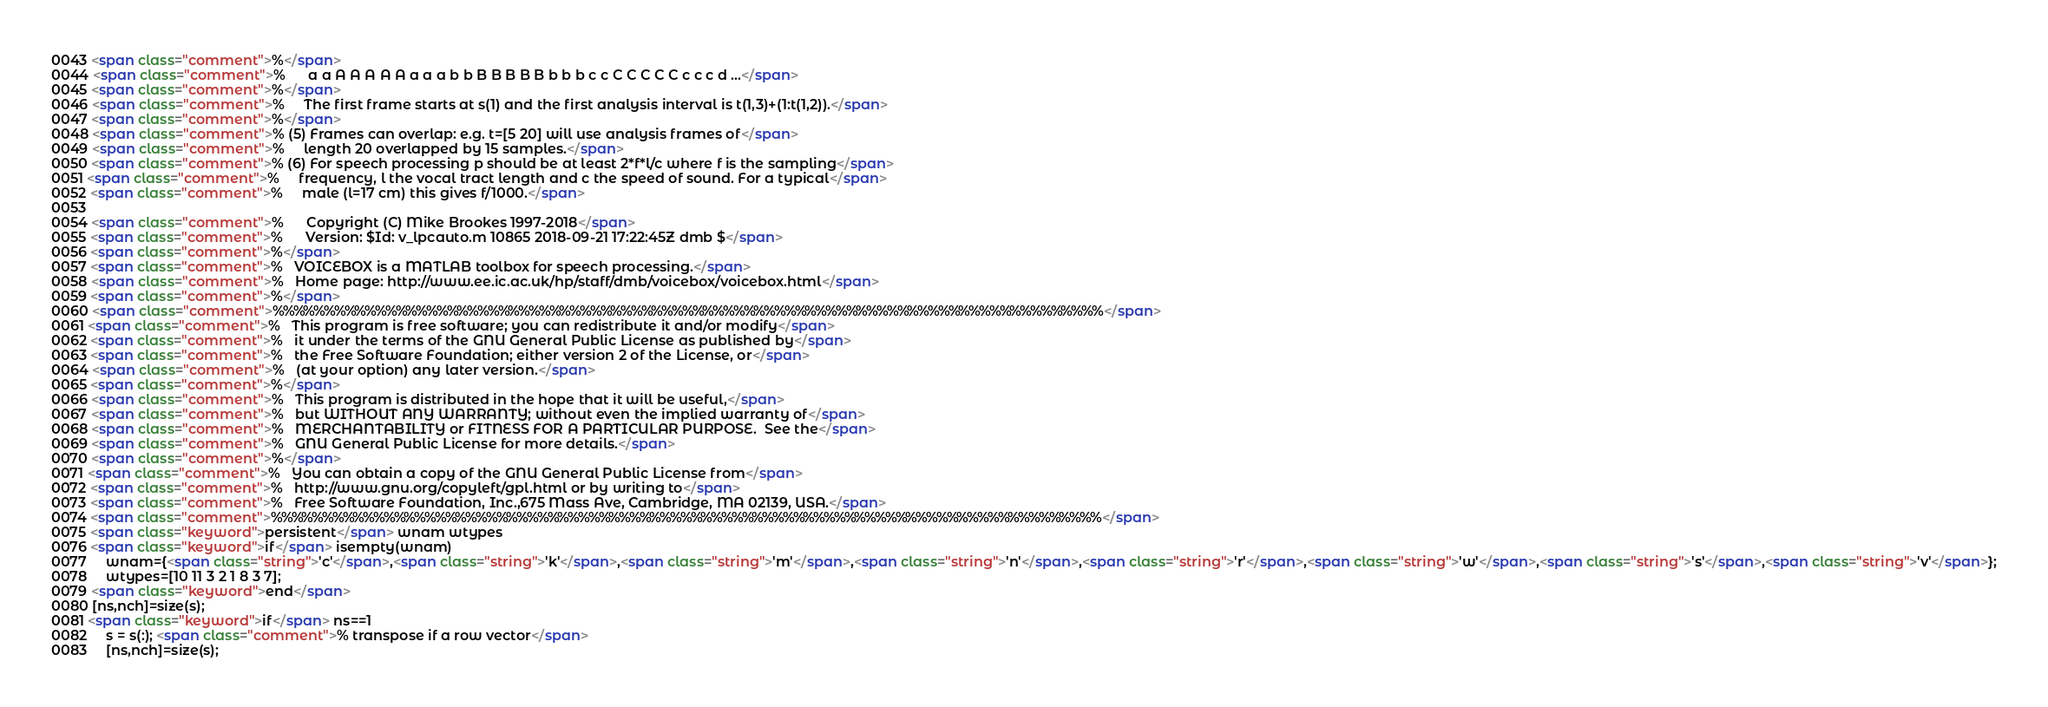<code> <loc_0><loc_0><loc_500><loc_500><_HTML_>0043 <span class="comment">%</span>
0044 <span class="comment">%      a a A A A A A a a a b b B B B B B b b b c c C C C C C c c c d ...</span>
0045 <span class="comment">%</span>
0046 <span class="comment">%     The first frame starts at s(1) and the first analysis interval is t(1,3)+(1:t(1,2)).</span>
0047 <span class="comment">%</span>
0048 <span class="comment">% (5) Frames can overlap: e.g. t=[5 20] will use analysis frames of</span>
0049 <span class="comment">%     length 20 overlapped by 15 samples.</span>
0050 <span class="comment">% (6) For speech processing p should be at least 2*f*l/c where f is the sampling</span>
0051 <span class="comment">%     frequency, l the vocal tract length and c the speed of sound. For a typical</span>
0052 <span class="comment">%     male (l=17 cm) this gives f/1000.</span>
0053 
0054 <span class="comment">%      Copyright (C) Mike Brookes 1997-2018</span>
0055 <span class="comment">%      Version: $Id: v_lpcauto.m 10865 2018-09-21 17:22:45Z dmb $</span>
0056 <span class="comment">%</span>
0057 <span class="comment">%   VOICEBOX is a MATLAB toolbox for speech processing.</span>
0058 <span class="comment">%   Home page: http://www.ee.ic.ac.uk/hp/staff/dmb/voicebox/voicebox.html</span>
0059 <span class="comment">%</span>
0060 <span class="comment">%%%%%%%%%%%%%%%%%%%%%%%%%%%%%%%%%%%%%%%%%%%%%%%%%%%%%%%%%%%%%%%%%%%%%%%%%%%%%%%%%</span>
0061 <span class="comment">%   This program is free software; you can redistribute it and/or modify</span>
0062 <span class="comment">%   it under the terms of the GNU General Public License as published by</span>
0063 <span class="comment">%   the Free Software Foundation; either version 2 of the License, or</span>
0064 <span class="comment">%   (at your option) any later version.</span>
0065 <span class="comment">%</span>
0066 <span class="comment">%   This program is distributed in the hope that it will be useful,</span>
0067 <span class="comment">%   but WITHOUT ANY WARRANTY; without even the implied warranty of</span>
0068 <span class="comment">%   MERCHANTABILITY or FITNESS FOR A PARTICULAR PURPOSE.  See the</span>
0069 <span class="comment">%   GNU General Public License for more details.</span>
0070 <span class="comment">%</span>
0071 <span class="comment">%   You can obtain a copy of the GNU General Public License from</span>
0072 <span class="comment">%   http://www.gnu.org/copyleft/gpl.html or by writing to</span>
0073 <span class="comment">%   Free Software Foundation, Inc.,675 Mass Ave, Cambridge, MA 02139, USA.</span>
0074 <span class="comment">%%%%%%%%%%%%%%%%%%%%%%%%%%%%%%%%%%%%%%%%%%%%%%%%%%%%%%%%%%%%%%%%%%%%%%%%%%%%%%%%%</span>
0075 <span class="keyword">persistent</span> wnam wtypes
0076 <span class="keyword">if</span> isempty(wnam)
0077     wnam={<span class="string">'c'</span>,<span class="string">'k'</span>,<span class="string">'m'</span>,<span class="string">'n'</span>,<span class="string">'r'</span>,<span class="string">'w'</span>,<span class="string">'s'</span>,<span class="string">'v'</span>};
0078     wtypes=[10 11 3 2 1 8 3 7];
0079 <span class="keyword">end</span>
0080 [ns,nch]=size(s);
0081 <span class="keyword">if</span> ns==1
0082     s = s(:); <span class="comment">% transpose if a row vector</span>
0083     [ns,nch]=size(s);</code> 